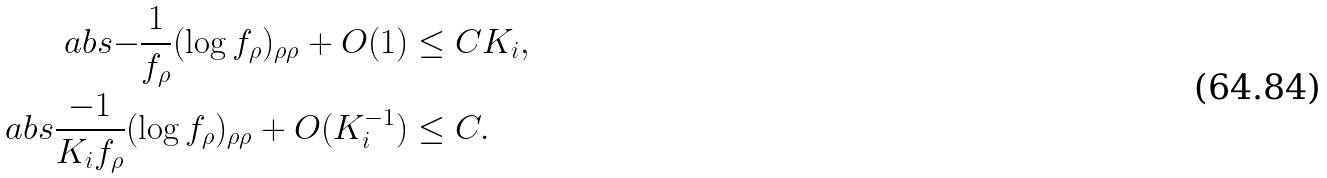<formula> <loc_0><loc_0><loc_500><loc_500>\ a b s { - \frac { 1 } { f _ { \rho } } ( \log f _ { \rho } ) _ { \rho \rho } + O ( 1 ) } & \leq C K _ { i } , \\ \ a b s { \frac { - 1 } { K _ { i } f _ { \rho } } ( \log f _ { \rho } ) _ { \rho \rho } + O ( K ^ { - 1 } _ { i } ) } & \leq C .</formula> 